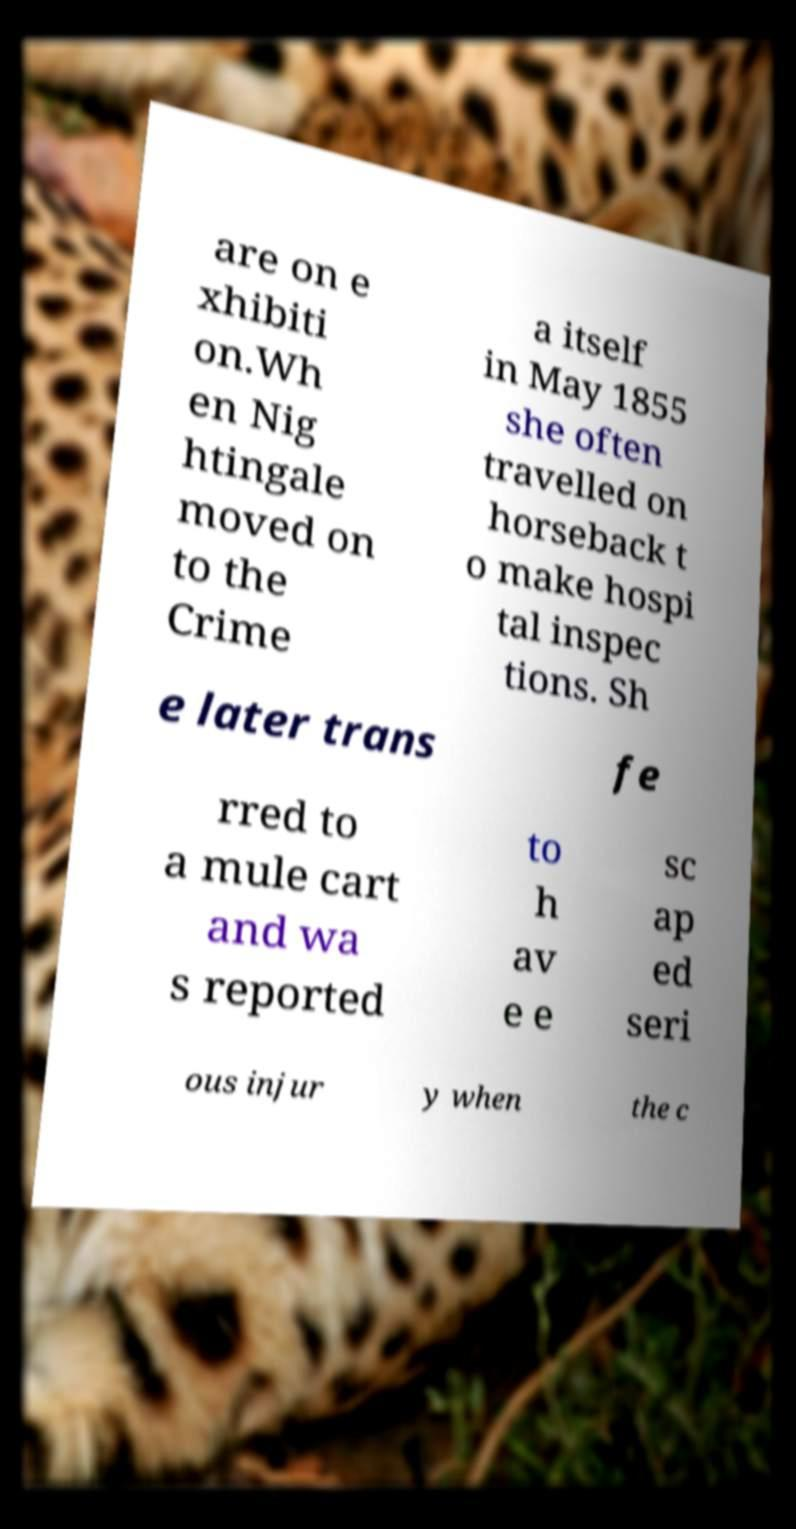Can you read and provide the text displayed in the image?This photo seems to have some interesting text. Can you extract and type it out for me? are on e xhibiti on.Wh en Nig htingale moved on to the Crime a itself in May 1855 she often travelled on horseback t o make hospi tal inspec tions. Sh e later trans fe rred to a mule cart and wa s reported to h av e e sc ap ed seri ous injur y when the c 